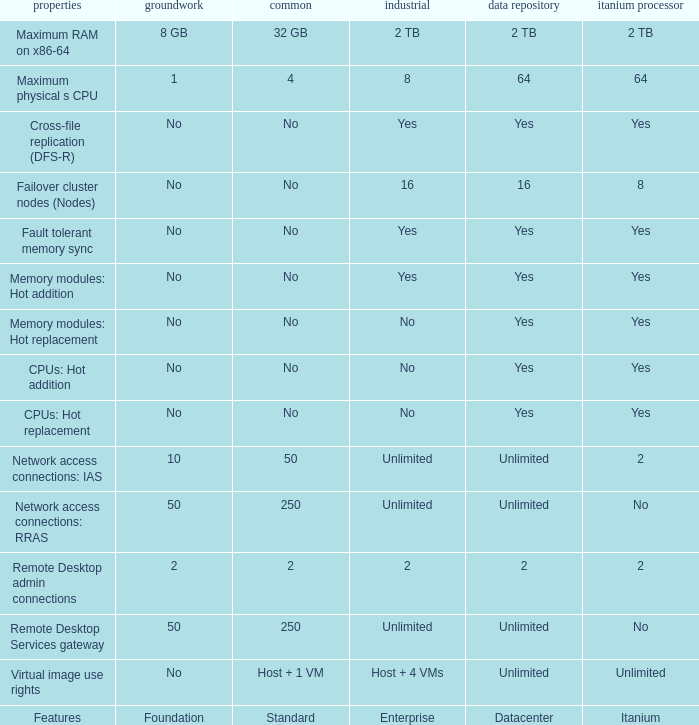In which data center is the fault tolerant memory sync feature available for itanium and not for standard? Yes. 